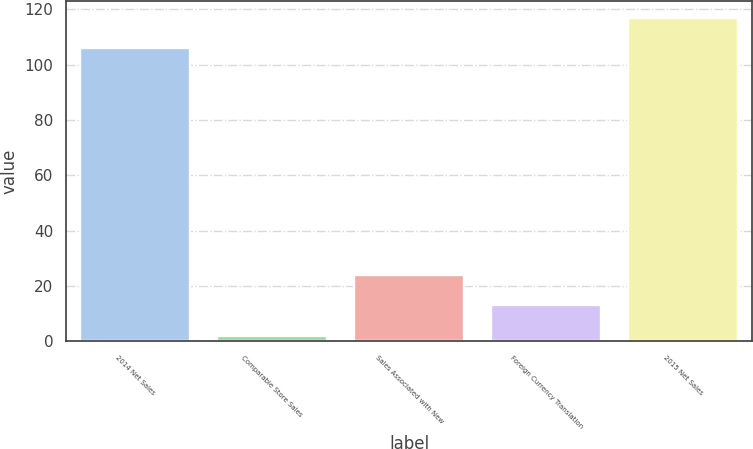Convert chart to OTSL. <chart><loc_0><loc_0><loc_500><loc_500><bar_chart><fcel>2014 Net Sales<fcel>Comparable Store Sales<fcel>Sales Associated with New<fcel>Foreign Currency Translation<fcel>2015 Net Sales<nl><fcel>106<fcel>2<fcel>24<fcel>13<fcel>117<nl></chart> 